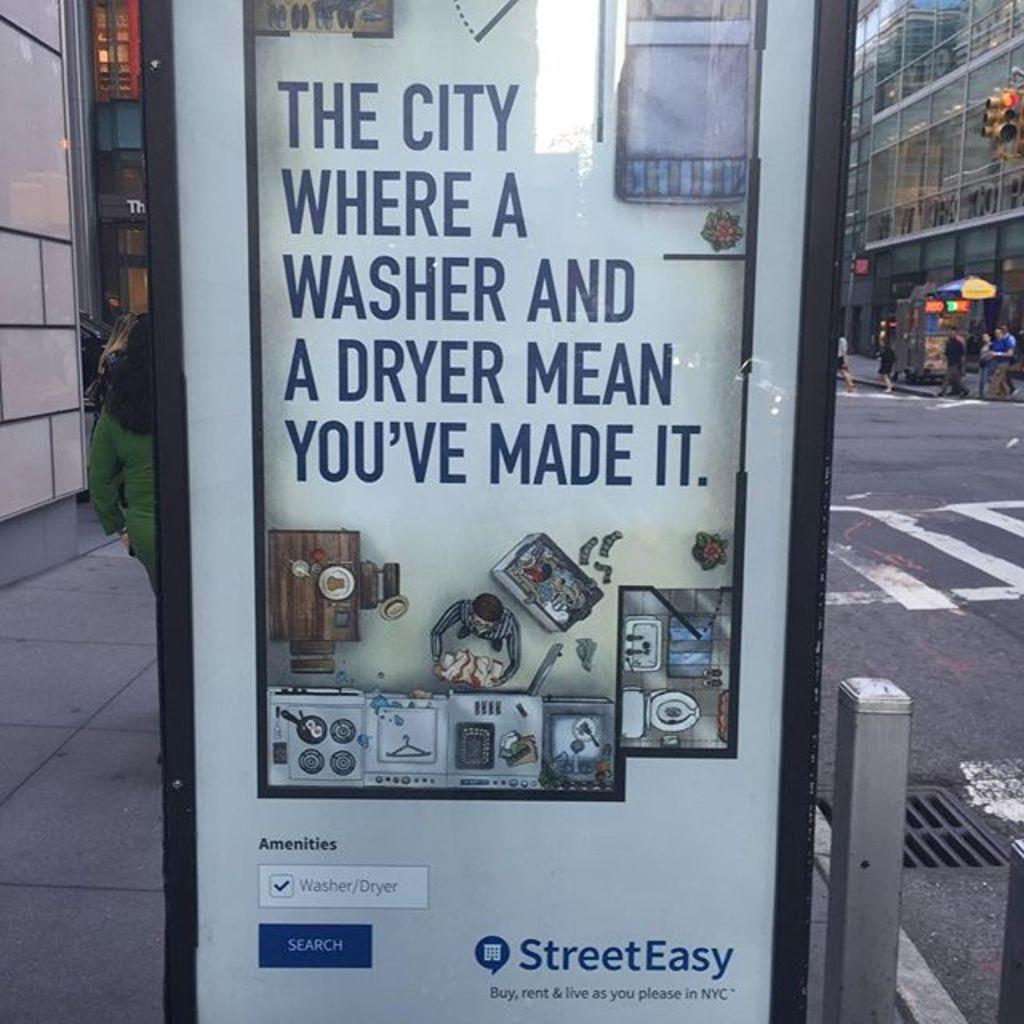<image>
Render a clear and concise summary of the photo. an advertisement outside that has StreetEasy on it 